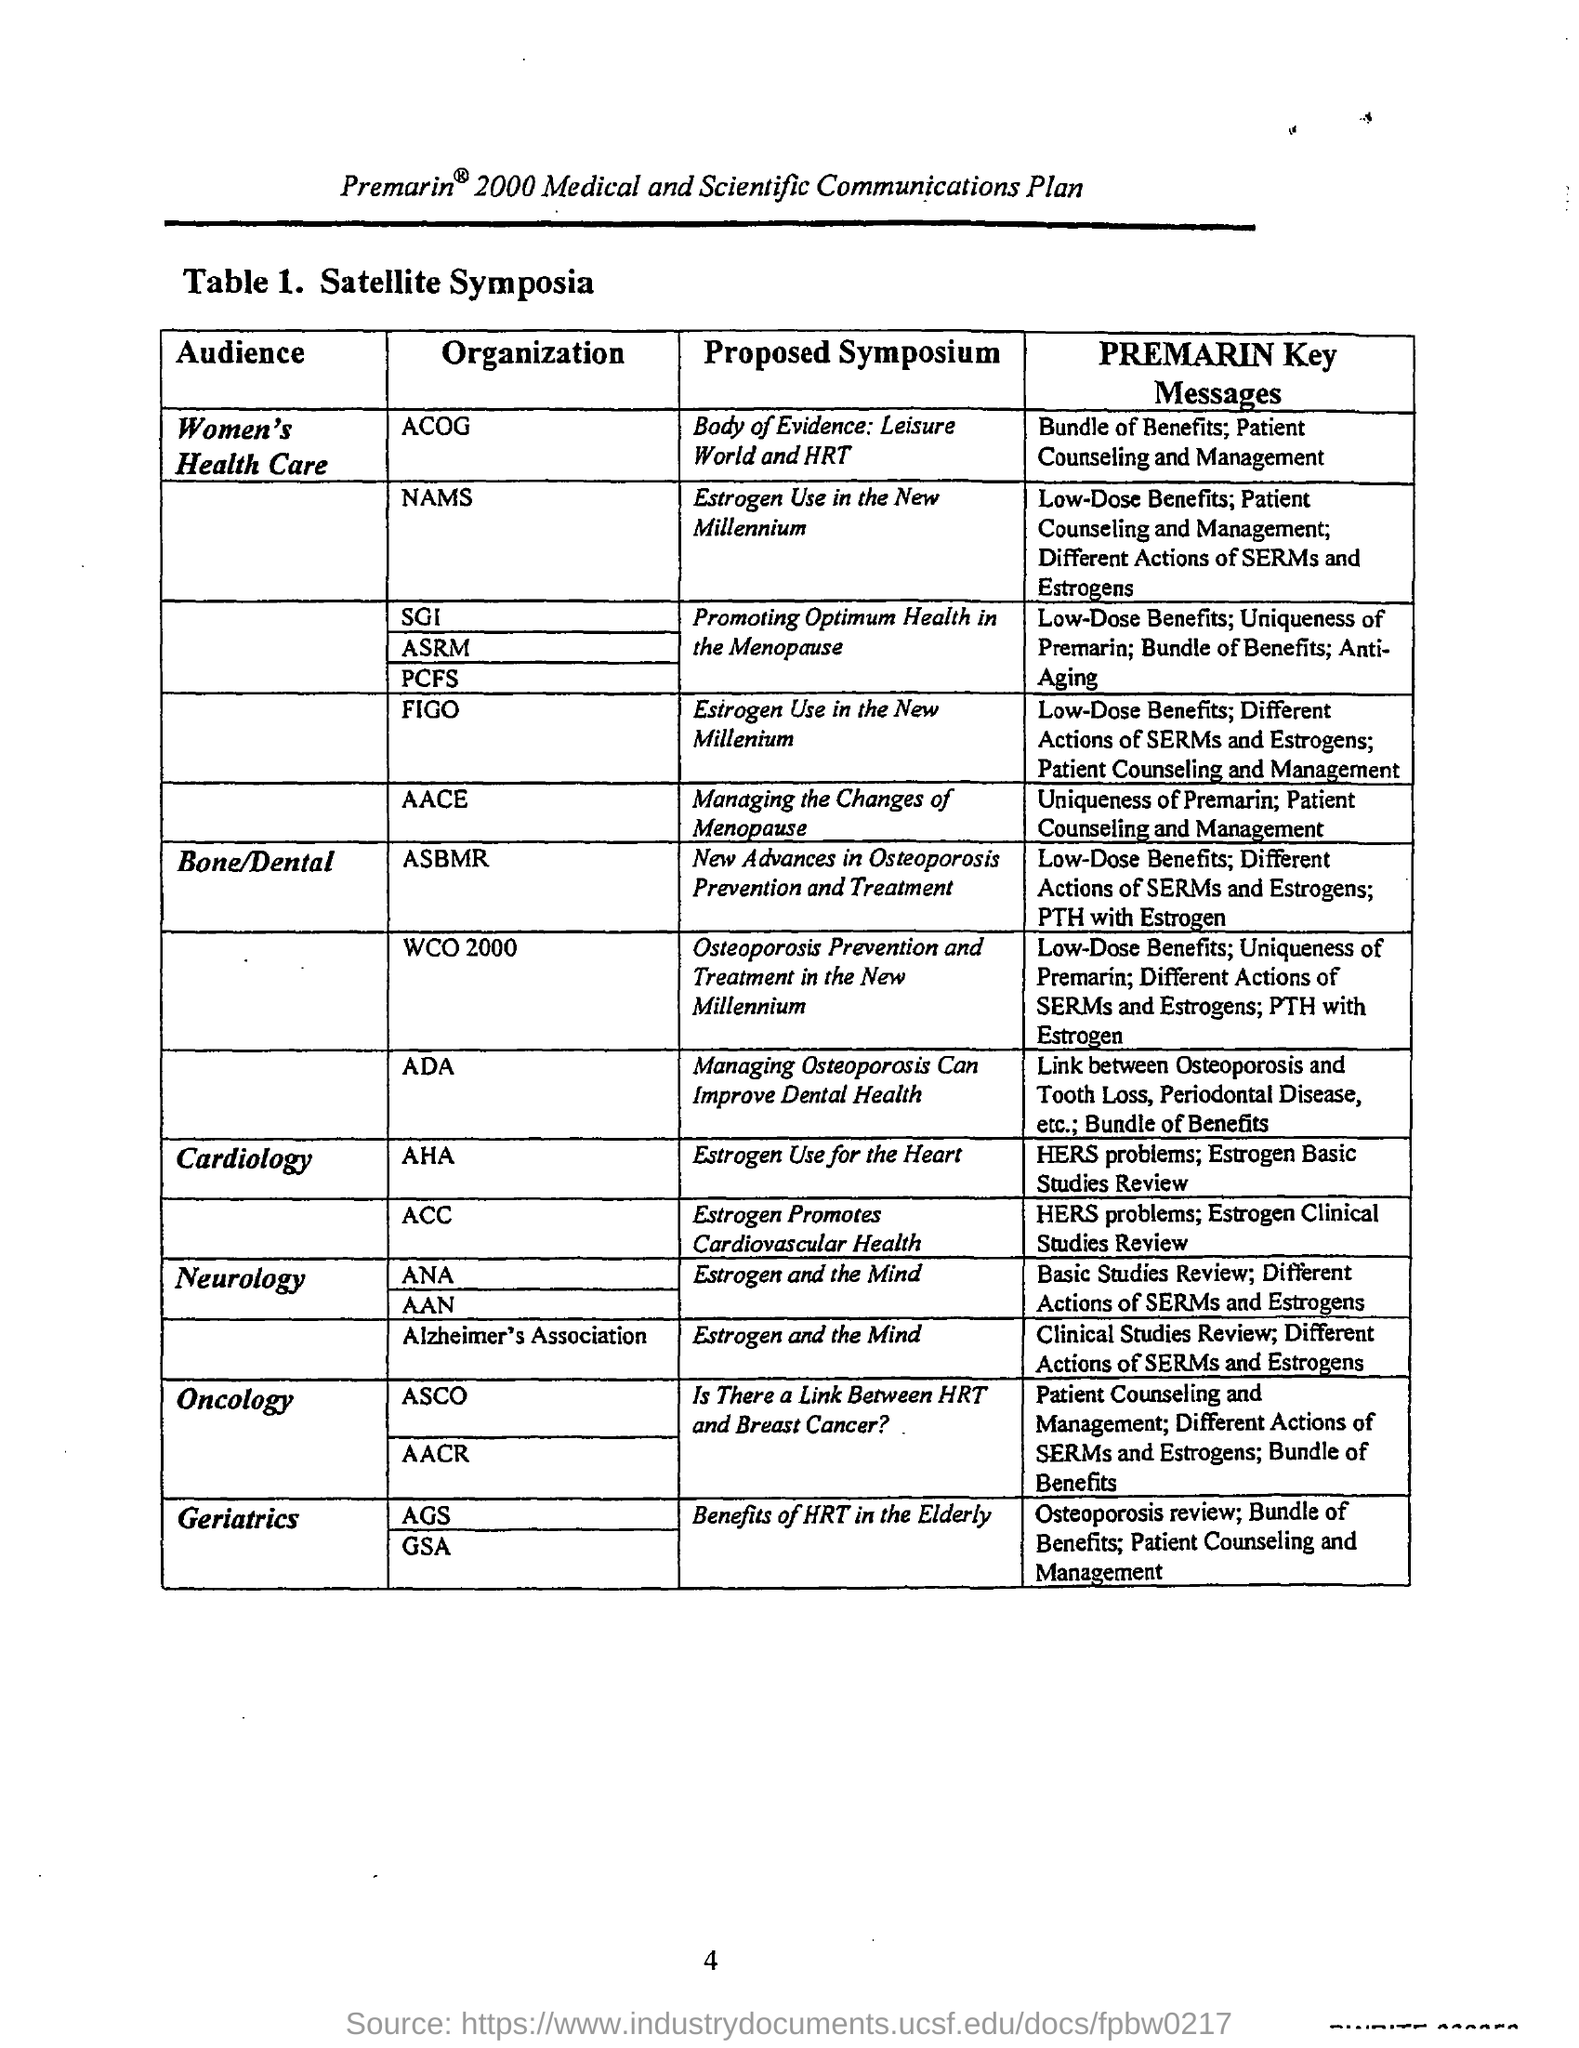Indicate a few pertinent items in this graphic. The audience for "Body of Evidence" is women's health care. Premarin is a unique medication that is essential for patient counselling and management. Key messages from the American Association of Clinical Endocrinologists (AACE) emphasize the importance of proper patient counselling and management when using Premarin. 